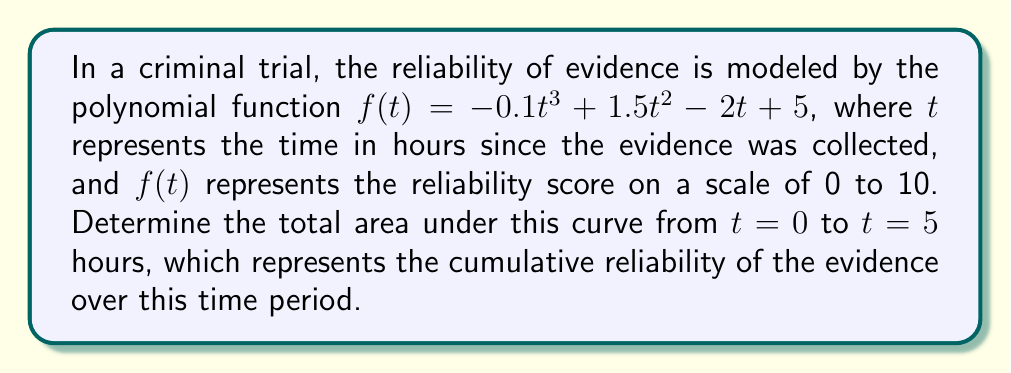Teach me how to tackle this problem. To find the area under the curve, we need to calculate the definite integral of $f(t)$ from $t = 0$ to $t = 5$. Let's break this down step-by-step:

1) The integral of $f(t) = -0.1t^3 + 1.5t^2 - 2t + 5$ is:

   $F(t) = -0.025t^4 + 0.5t^3 - t^2 + 5t + C$

2) We need to evaluate $\int_0^5 f(t) dt = F(5) - F(0)$

3) Let's calculate $F(5)$:
   $F(5) = -0.025(5^4) + 0.5(5^3) - (5^2) + 5(5)$
         $= -15.625 + 62.5 - 25 + 25$
         $= 46.875$

4) Now, $F(0)$:
   $F(0) = -0.025(0^4) + 0.5(0^3) - (0^2) + 5(0) = 0$

5) Therefore, the area is:
   $F(5) - F(0) = 46.875 - 0 = 46.875$

This value represents the cumulative reliability of the evidence over the 5-hour period.
Answer: 46.875 reliability-hours 